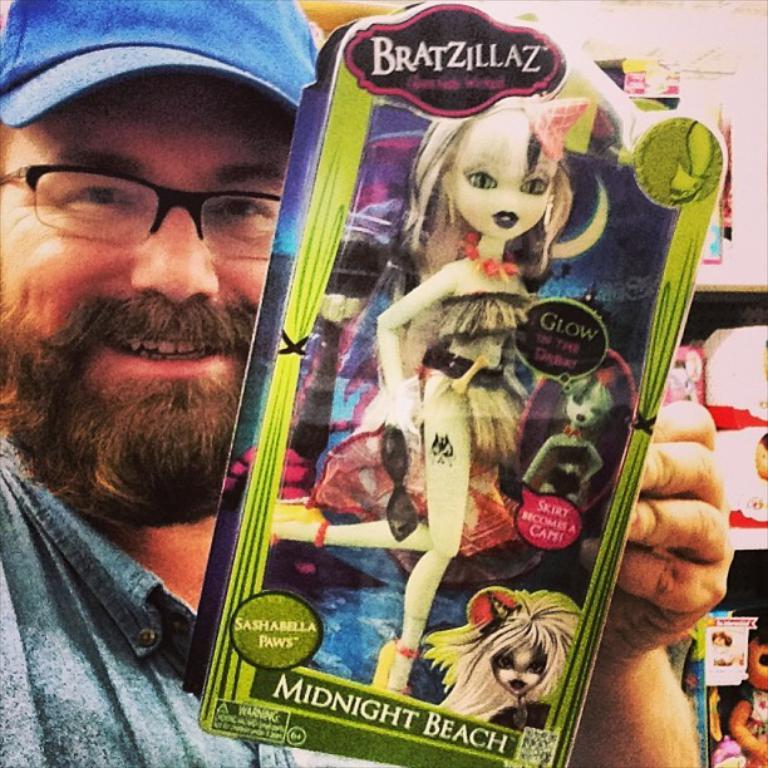Who is present in the image? There is a man in the image. What is the man holding in his hand? The man is holding a toy packet in his hand. What can be seen in the background of the image? There are packets and toys on the racks in the background of the image. What type of weather can be seen in the image? There is no information about the weather in the image; it only shows a man holding a toy packet and the background with packets and toys on racks. 